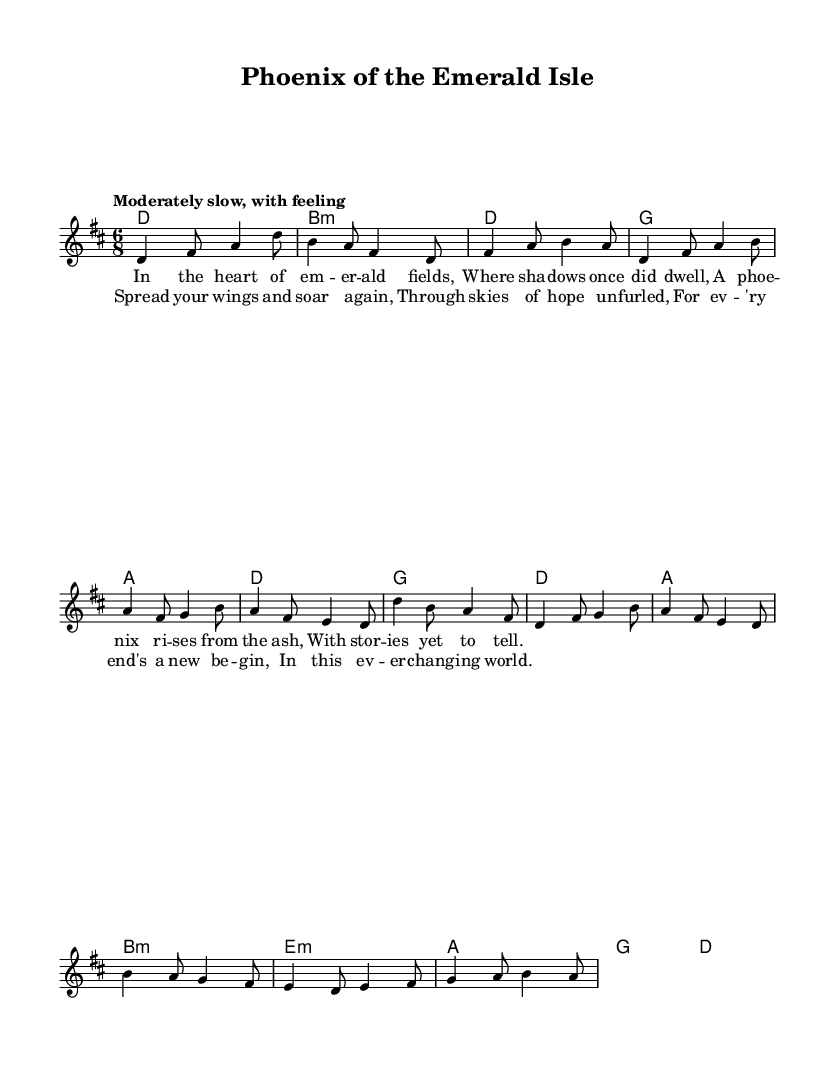What is the key signature of this music? The key signature is indicated at the beginning of the staff and shows two sharps, which corresponds to D major.
Answer: D major What is the time signature of this music? The time signature is found at the beginning of the staff and shows a 6 over 8, indicating a compound time signature.
Answer: 6/8 What is the tempo marking for this piece? The tempo marking is specified in the score and indicates a moderately slow pace with feeling, which guides the performance speed.
Answer: Moderately slow, with feeling How many verses are present in this piece? Counting the lyrics sections in the score, there is one verse indicated before the chorus and no additional verses are provided in the sheet music.
Answer: One verse What does the chorus suggest about resilience and new beginnings? The lyrics of the chorus emphasize themes of renewal and hope, stating that every end leads to a new beginning, encouraging a positive outlook despite challenges.
Answer: Every end's a new begin What type of chord is used in the bridge section? The bridge section features an E minor chord, which is marked with a colon followed by the letter 'm' indicating its minor quality.
Answer: E minor Which folkloric theme does this ballad embody? The ballad embodies themes common in Celtic folk music, specifically resilience and the idea of overcoming challenges, as represented in the lyrics.
Answer: Resilience 